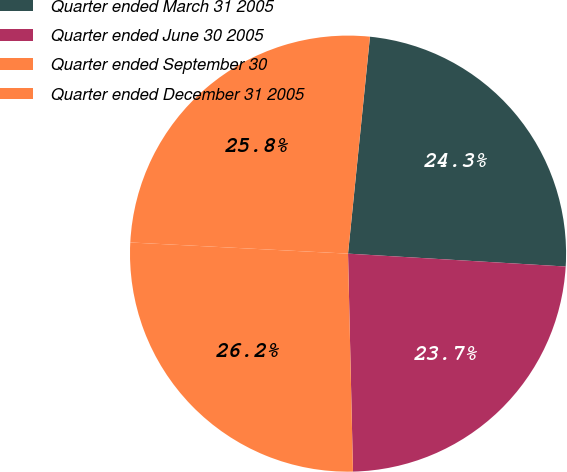Convert chart to OTSL. <chart><loc_0><loc_0><loc_500><loc_500><pie_chart><fcel>Quarter ended March 31 2005<fcel>Quarter ended June 30 2005<fcel>Quarter ended September 30<fcel>Quarter ended December 31 2005<nl><fcel>24.34%<fcel>23.7%<fcel>26.18%<fcel>25.79%<nl></chart> 